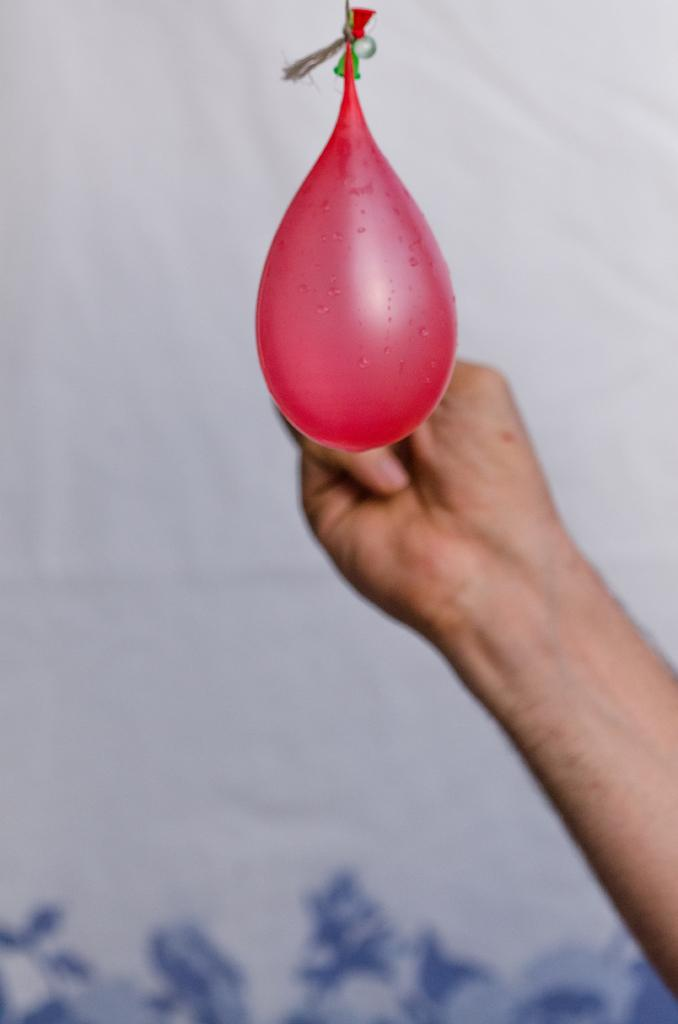What is the main object in the center of the image? There is a water balloon in the center of the image. What can be seen on the right side of the image? There is a person's hand on the right side of the image. What color is the curtain in the background of the image? There is a white color curtain in the background of the image. What type of nose can be seen on the water balloon in the image? There is no nose present on the water balloon in the image. 